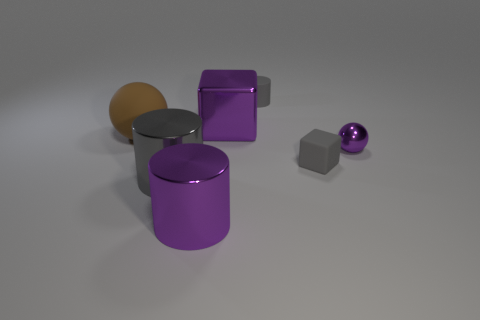What is the color of the small cube that is made of the same material as the big sphere?
Make the answer very short. Gray. Are there any small cyan blocks that have the same material as the tiny purple ball?
Your answer should be compact. No. What number of things are either small red spheres or small things?
Your answer should be compact. 3. Are the small purple thing and the big purple thing that is in front of the gray shiny object made of the same material?
Offer a terse response. Yes. There is a purple metallic thing in front of the large gray shiny thing; what size is it?
Offer a very short reply. Large. Are there fewer large red spheres than large purple metal cubes?
Offer a very short reply. Yes. Is there a rubber cylinder of the same color as the tiny ball?
Provide a succinct answer. No. There is a object that is both behind the big brown matte ball and left of the rubber cylinder; what shape is it?
Offer a very short reply. Cube. What shape is the big shiny thing that is behind the tiny gray object to the right of the small gray rubber cylinder?
Ensure brevity in your answer.  Cube. Does the big gray shiny thing have the same shape as the brown matte object?
Your answer should be compact. No. 